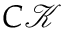<formula> <loc_0><loc_0><loc_500><loc_500>C \mathcal { K }</formula> 